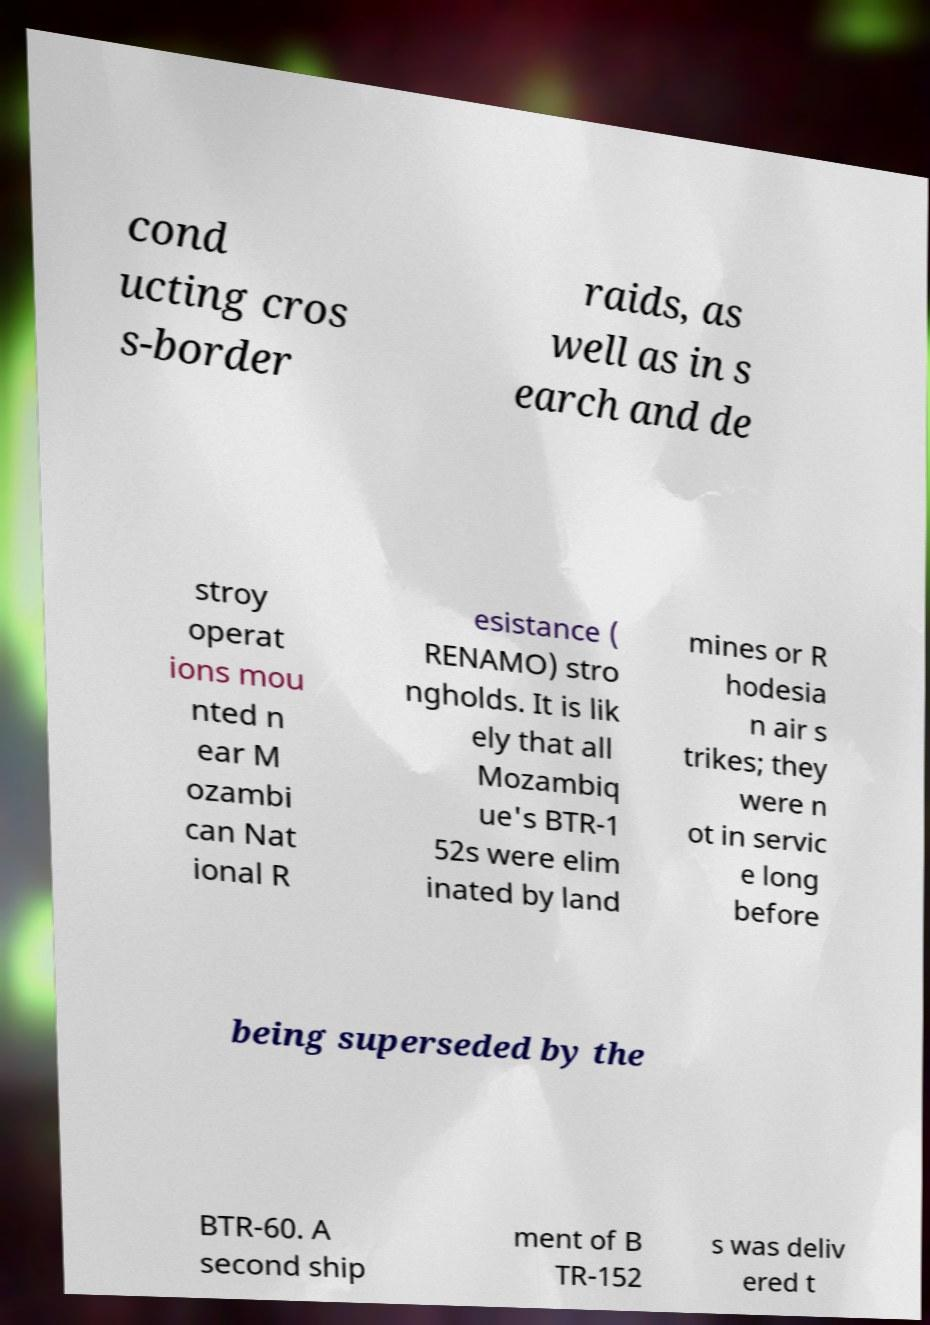For documentation purposes, I need the text within this image transcribed. Could you provide that? cond ucting cros s-border raids, as well as in s earch and de stroy operat ions mou nted n ear M ozambi can Nat ional R esistance ( RENAMO) stro ngholds. It is lik ely that all Mozambiq ue's BTR-1 52s were elim inated by land mines or R hodesia n air s trikes; they were n ot in servic e long before being superseded by the BTR-60. A second ship ment of B TR-152 s was deliv ered t 